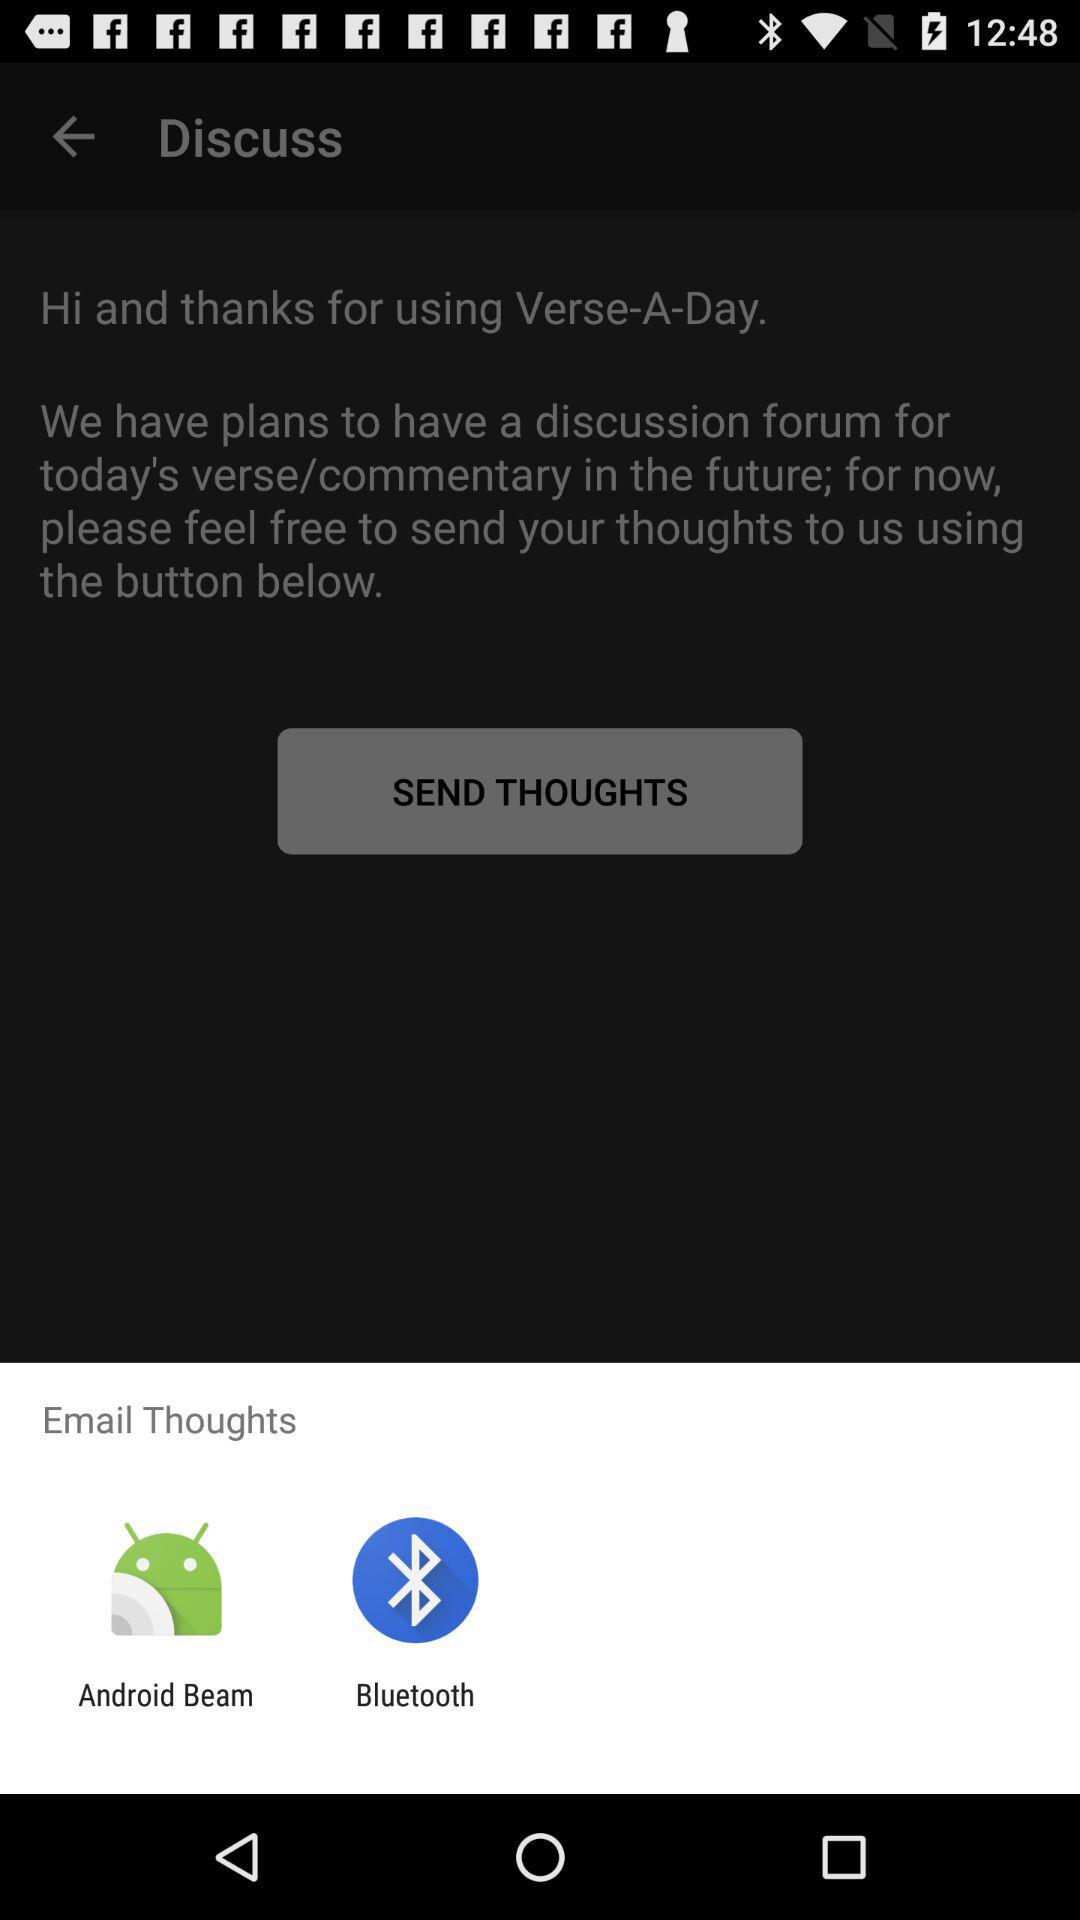Which options are given for the email thoughts? The options for email thoughts are "Android Beam" and "Bluetooth". 